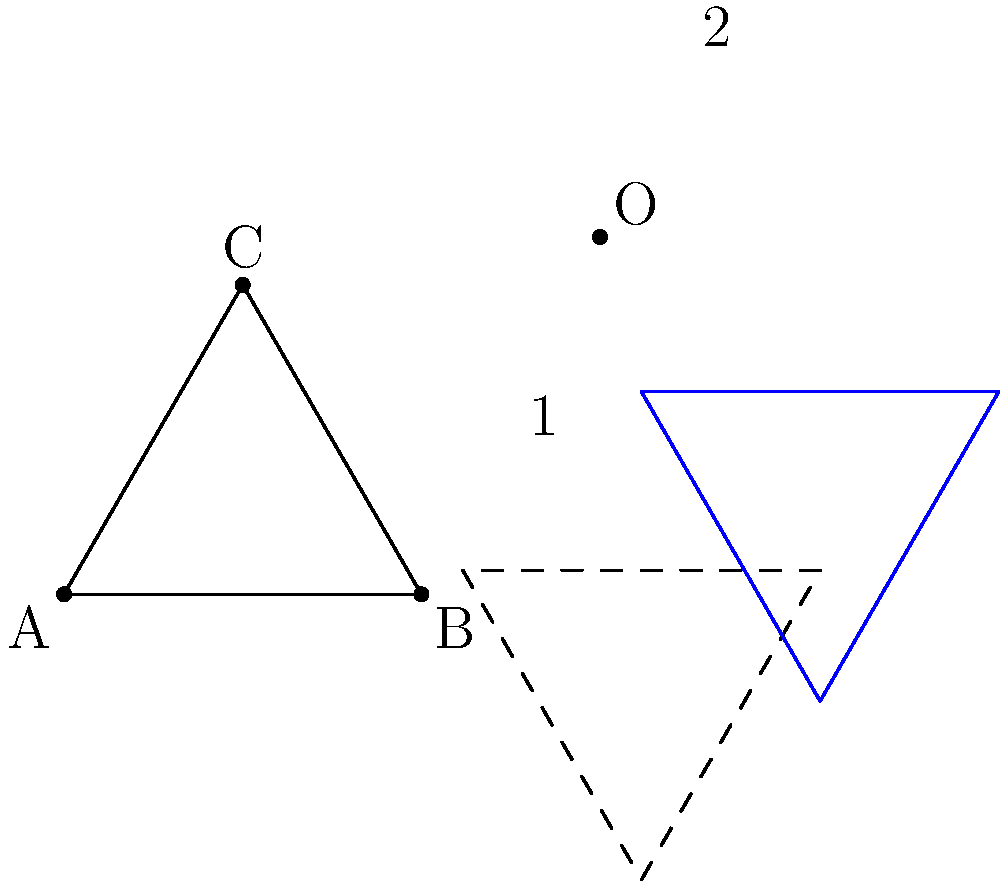An equilateral triangle ABC is first rotated 60° counterclockwise around point O, and then translated 1 unit right and 1 unit up. Given that the side length of the original triangle is 2 units, what is the area of the final triangle? Let's approach this step-by-step:

1) First, we need to recall that transformations (rotations and translations) preserve the shape and size of geometric figures.

2) The original triangle is equilateral with side length 2 units. To find its area, we can use the formula:

   $$A = \frac{\sqrt{3}}{4}a^2$$

   where $a$ is the side length.

3) Substituting $a = 2$:

   $$A = \frac{\sqrt{3}}{4}(2^2) = \sqrt{3}$$

4) The rotation doesn't change the area of the triangle.

5) The translation also doesn't change the area of the triangle.

6) Therefore, the area of the final triangle is the same as the area of the original triangle.
Answer: $\sqrt{3}$ square units 